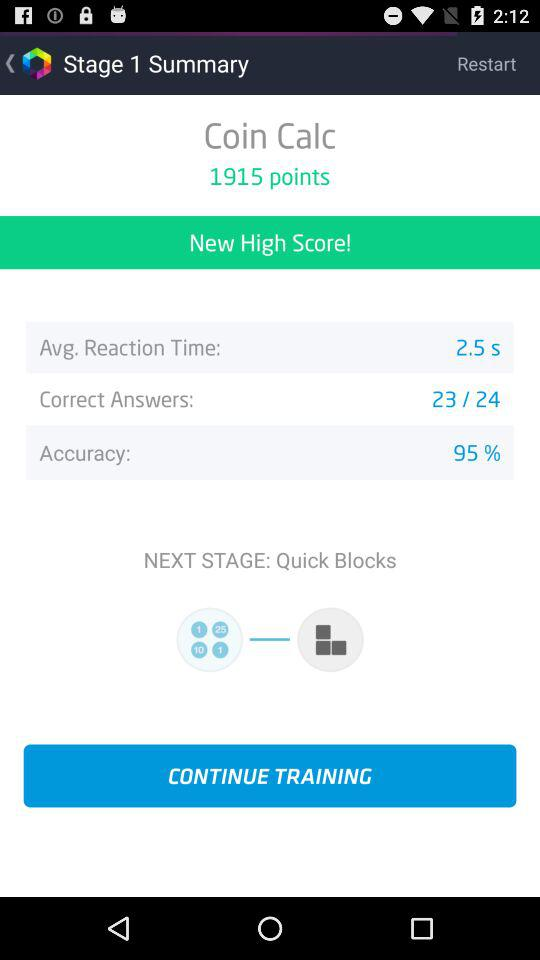How many points are there in the "Coin Calc"? There are 1915 points in the "Coin Calc". 